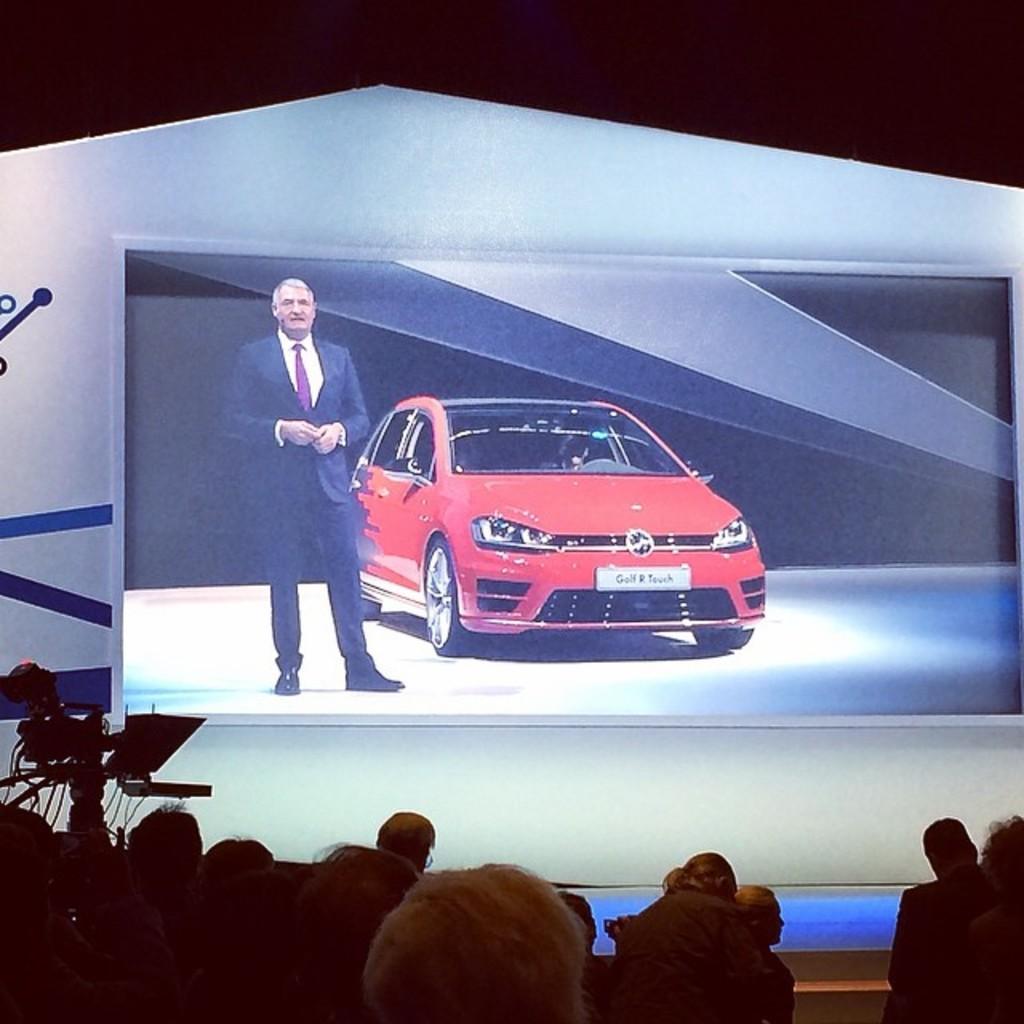In one or two sentences, can you explain what this image depicts? In the picture there is a huge picture of a car and a man is standing beside the car, in front of that image there are cameras and many people were gathered in a hall. 